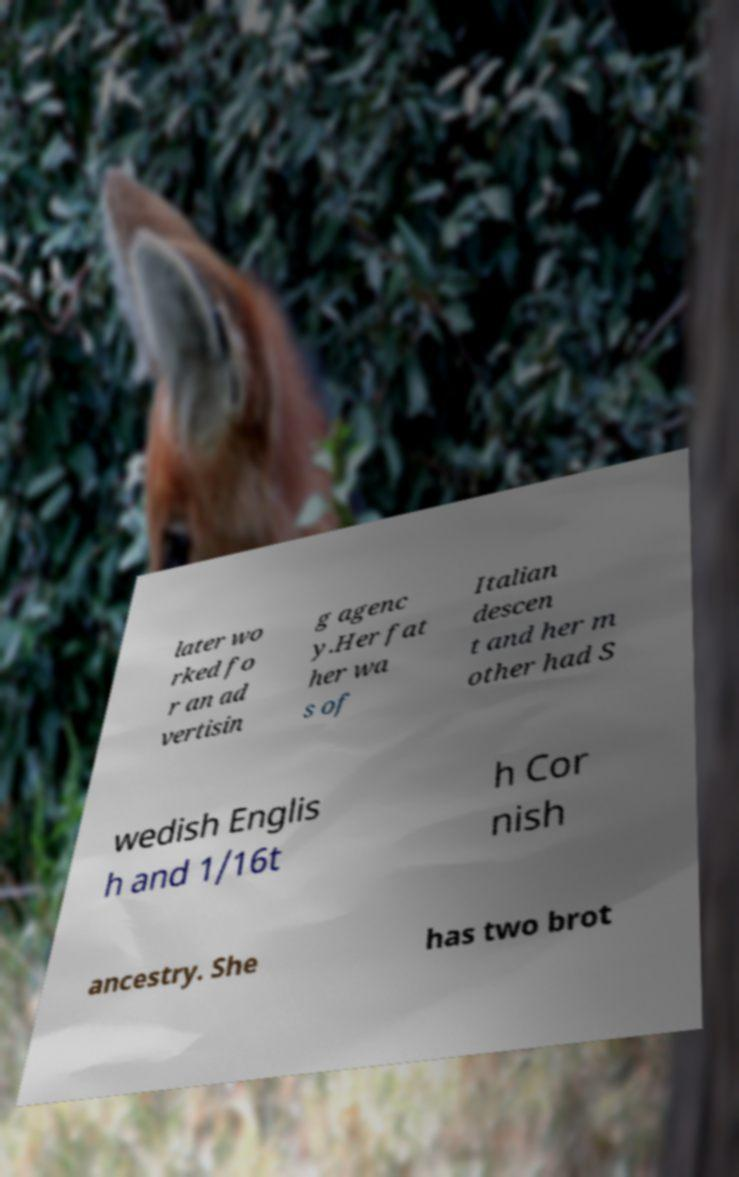Could you assist in decoding the text presented in this image and type it out clearly? later wo rked fo r an ad vertisin g agenc y.Her fat her wa s of Italian descen t and her m other had S wedish Englis h and 1/16t h Cor nish ancestry. She has two brot 